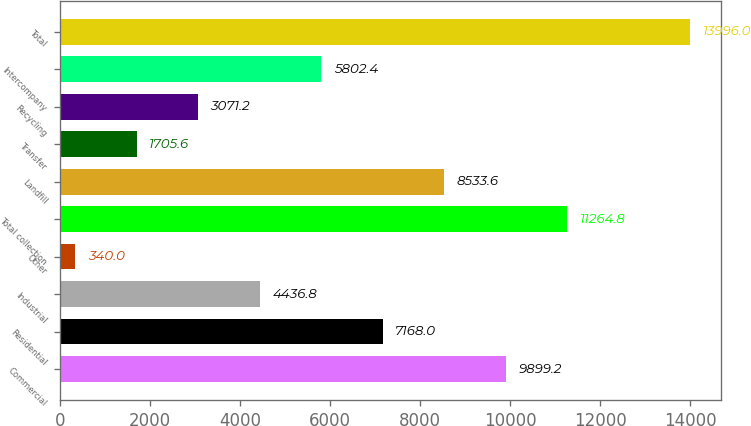Convert chart. <chart><loc_0><loc_0><loc_500><loc_500><bar_chart><fcel>Commercial<fcel>Residential<fcel>Industrial<fcel>Other<fcel>Total collection<fcel>Landfill<fcel>Transfer<fcel>Recycling<fcel>Intercompany<fcel>Total<nl><fcel>9899.2<fcel>7168<fcel>4436.8<fcel>340<fcel>11264.8<fcel>8533.6<fcel>1705.6<fcel>3071.2<fcel>5802.4<fcel>13996<nl></chart> 